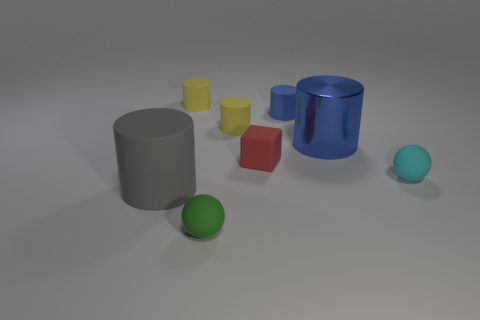Add 1 large blue blocks. How many objects exist? 9 Subtract all tiny matte cylinders. How many cylinders are left? 2 Subtract all gray blocks. How many yellow cylinders are left? 2 Subtract all green balls. How many balls are left? 1 Subtract all spheres. How many objects are left? 6 Subtract 0 brown cubes. How many objects are left? 8 Subtract 5 cylinders. How many cylinders are left? 0 Subtract all purple balls. Subtract all red cubes. How many balls are left? 2 Subtract all cyan spheres. Subtract all small purple cylinders. How many objects are left? 7 Add 6 metal cylinders. How many metal cylinders are left? 7 